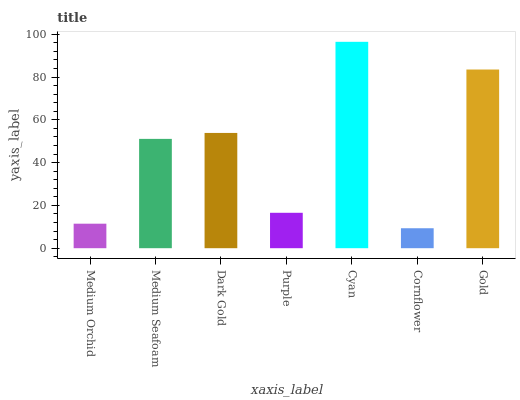Is Medium Seafoam the minimum?
Answer yes or no. No. Is Medium Seafoam the maximum?
Answer yes or no. No. Is Medium Seafoam greater than Medium Orchid?
Answer yes or no. Yes. Is Medium Orchid less than Medium Seafoam?
Answer yes or no. Yes. Is Medium Orchid greater than Medium Seafoam?
Answer yes or no. No. Is Medium Seafoam less than Medium Orchid?
Answer yes or no. No. Is Medium Seafoam the high median?
Answer yes or no. Yes. Is Medium Seafoam the low median?
Answer yes or no. Yes. Is Gold the high median?
Answer yes or no. No. Is Dark Gold the low median?
Answer yes or no. No. 